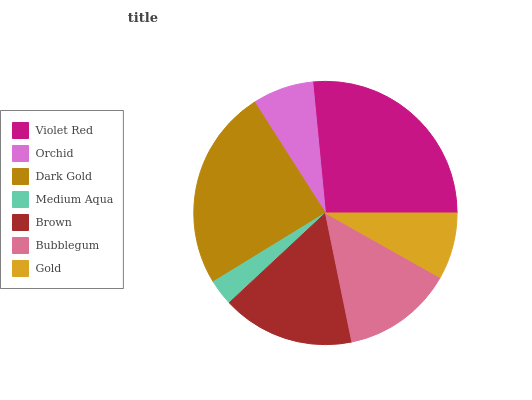Is Medium Aqua the minimum?
Answer yes or no. Yes. Is Violet Red the maximum?
Answer yes or no. Yes. Is Orchid the minimum?
Answer yes or no. No. Is Orchid the maximum?
Answer yes or no. No. Is Violet Red greater than Orchid?
Answer yes or no. Yes. Is Orchid less than Violet Red?
Answer yes or no. Yes. Is Orchid greater than Violet Red?
Answer yes or no. No. Is Violet Red less than Orchid?
Answer yes or no. No. Is Bubblegum the high median?
Answer yes or no. Yes. Is Bubblegum the low median?
Answer yes or no. Yes. Is Gold the high median?
Answer yes or no. No. Is Dark Gold the low median?
Answer yes or no. No. 